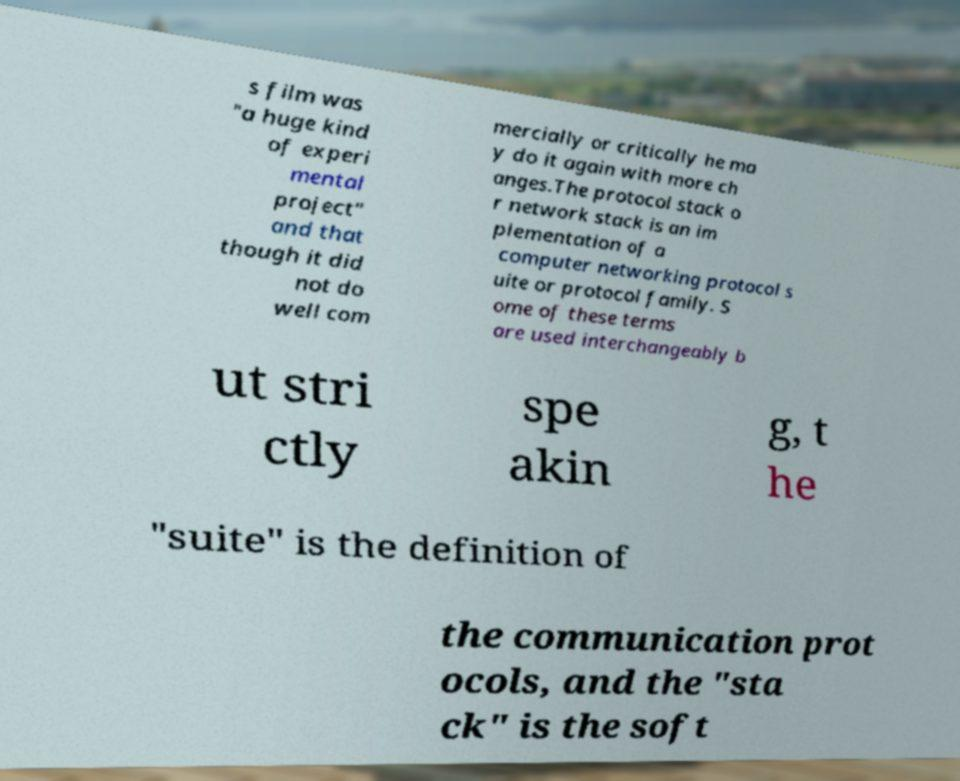Please identify and transcribe the text found in this image. s film was "a huge kind of experi mental project" and that though it did not do well com mercially or critically he ma y do it again with more ch anges.The protocol stack o r network stack is an im plementation of a computer networking protocol s uite or protocol family. S ome of these terms are used interchangeably b ut stri ctly spe akin g, t he "suite" is the definition of the communication prot ocols, and the "sta ck" is the soft 